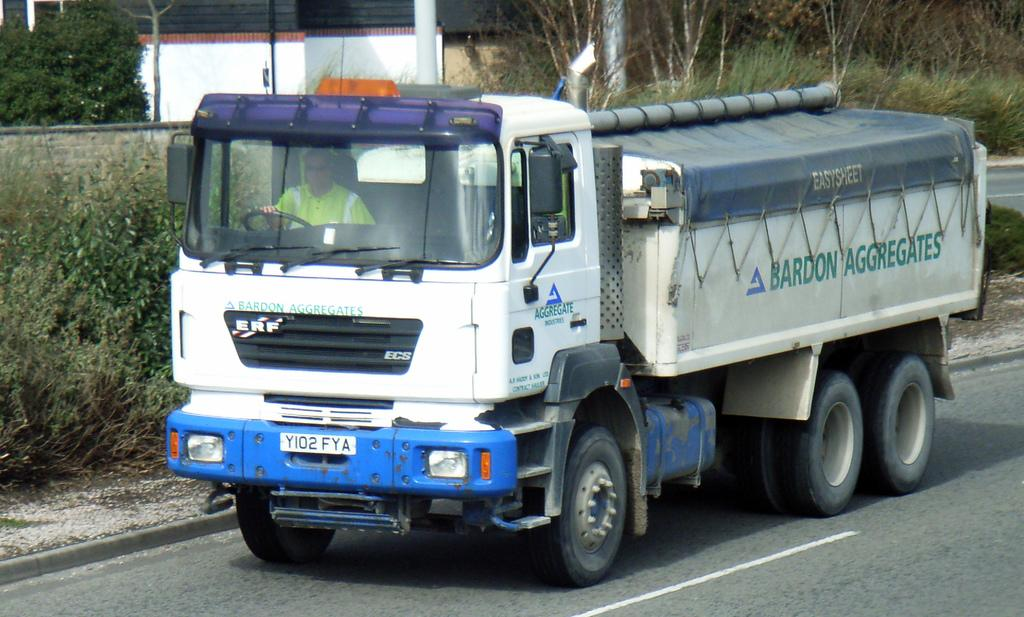What is the person in the image doing? There is a person sitting in a truck in the image. Where is the truck located? The truck is on the road. What can be seen in the background of the image? There are trees, poles, a wall, and a building in the background of the image. What type of drink is the person holding in the image? There is no drink visible in the image; the person is sitting in a truck. 